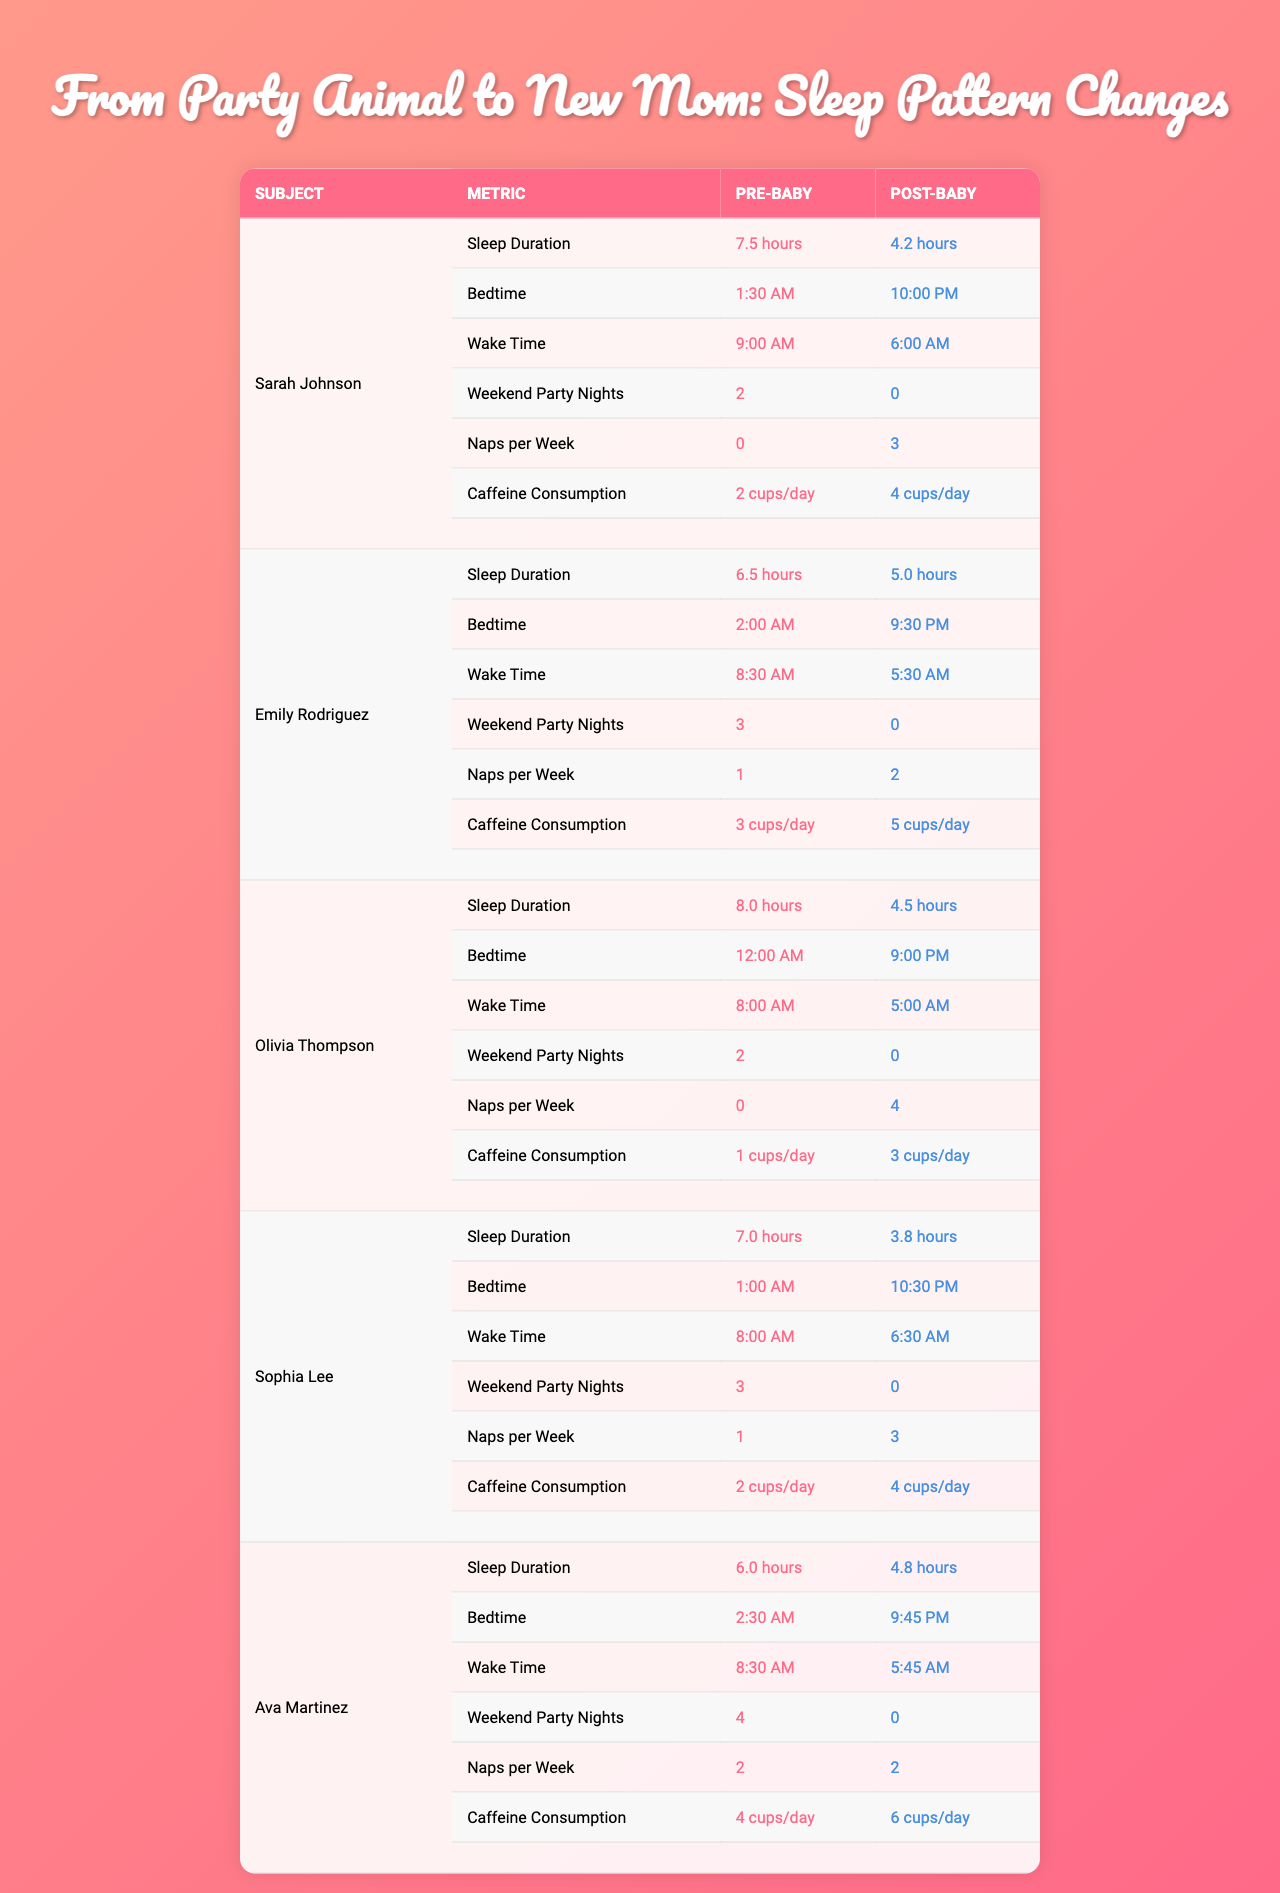What was Sarah's pre-baby sleep duration? The table shows that Sarah's pre-baby sleep duration was 7.5 hours.
Answer: 7.5 hours How much did Emily's sleep duration decrease after having a baby? Emily's pre-baby sleep duration was 6.5 hours and post-baby sleep duration is 5.0 hours. Therefore, the decrease is 6.5 - 5.0 = 1.5 hours.
Answer: 1.5 hours Did any mother continue to party on weekends after having a baby? The table states that all subjects reported 0 weekend party nights post-baby, indicating none continued partying on weekends.
Answer: No What is the average post-baby sleep duration among the mothers? The post-baby sleep durations are 4.2, 5.0, 4.5, 3.8, and 4.8. Summing them gives 4.2 + 5.0 + 4.5 + 3.8 + 4.8 = 22.3 hours. There are 5 subjects, so the average is 22.3 / 5 = 4.46 hours.
Answer: 4.46 hours How many more naps per week did Olivia take after having a baby? Olivia had 0 naps pre-baby and 4 naps post-baby. Thus, the increase is 4 - 0 = 4.
Answer: 4 naps Who had the earliest post-baby bedtime? By looking at the bedtimes, Olivia had a post-baby bedtime of 9:00 PM, which is earlier than the other subjects' bedtimes.
Answer: Olivia What is the difference in caffeine consumption before and after for Ava? Ava consumed 4 cups of caffeine per day pre-baby and 6 cups post-baby. The difference is 6 - 4 = 2 cups.
Answer: 2 cups How does the average pre-baby caffeine consumption compare to the post-baby average? The pre-baby averages are 2, 3, 1, 2, and 4 cups per day, totaling 12 cups, so average is 12 / 5 = 2.4 cups. The post-baby averages are 4, 5, 3, 4, and 6 cups, totaling 22 cups, averaging 22 / 5 = 4.4 cups. Thus, post-baby consumption is 4.4 - 2.4 = 2 cups higher.
Answer: 2 cups higher Which mother saw the largest change in wake time after having a baby? Ava woke up at 8:30 AM pre-baby and at 5:45 AM post-baby. The change is from 8:30 AM to 5:45 AM which is a 2 hour and 45 minute change earlier. Comparing all mothers, Ava had the largest change.
Answer: Ava Is it true that all mothers reduced their pre-baby weekend party nights to zero post-baby? The data shows that all subjects reported 0 weekend party nights after having a baby, confirming that this statement is true.
Answer: Yes 